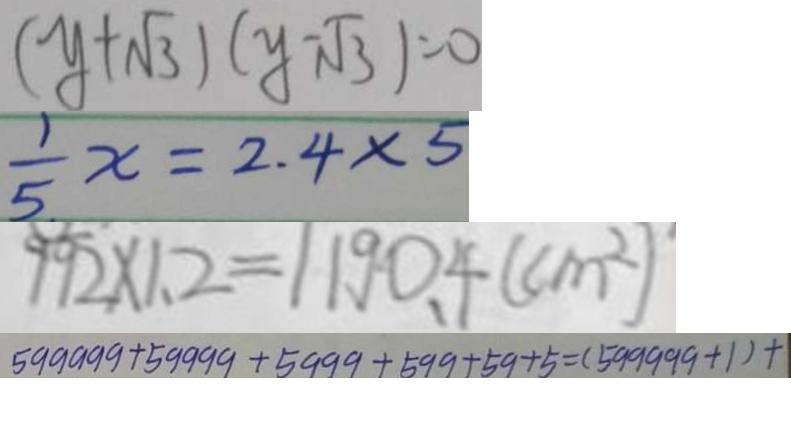Convert formula to latex. <formula><loc_0><loc_0><loc_500><loc_500>( y + \sqrt { 3 } ) ( y - \sqrt { 3 } ) = 0 
 \frac { 1 } { 5 } x = 2 . 4 \times 5 
 9 9 2 \times 1 . 2 = 1 1 9 0 . 4 ( c m ^ { 2 } ) 
 5 9 9 9 9 9 + 5 9 9 9 9 + 5 9 9 9 + 5 9 9 + 5 9 + 5 = ( 5 9 9 9 9 9 + 1 ) + 1</formula> 